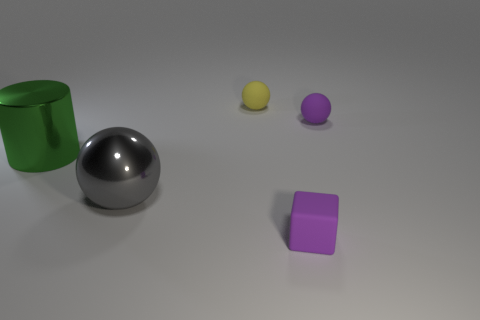What number of tiny purple balls are right of the small purple object that is in front of the green shiny thing?
Offer a very short reply. 1. What number of tiny things have the same material as the tiny purple ball?
Offer a terse response. 2. How many large objects are either gray blocks or yellow objects?
Your answer should be compact. 0. There is a object that is both behind the large gray ball and to the left of the yellow matte ball; what shape is it?
Give a very brief answer. Cylinder. Is the big green cylinder made of the same material as the yellow object?
Provide a short and direct response. No. What color is the cube that is the same size as the purple sphere?
Give a very brief answer. Purple. The object that is both behind the gray object and on the left side of the small yellow rubber object is what color?
Provide a succinct answer. Green. What size is the thing that is the same color as the rubber block?
Offer a very short reply. Small. What shape is the object that is the same color as the tiny cube?
Keep it short and to the point. Sphere. There is a purple matte object on the right side of the purple rubber object that is in front of the shiny thing in front of the big green metal thing; what size is it?
Your response must be concise. Small. 